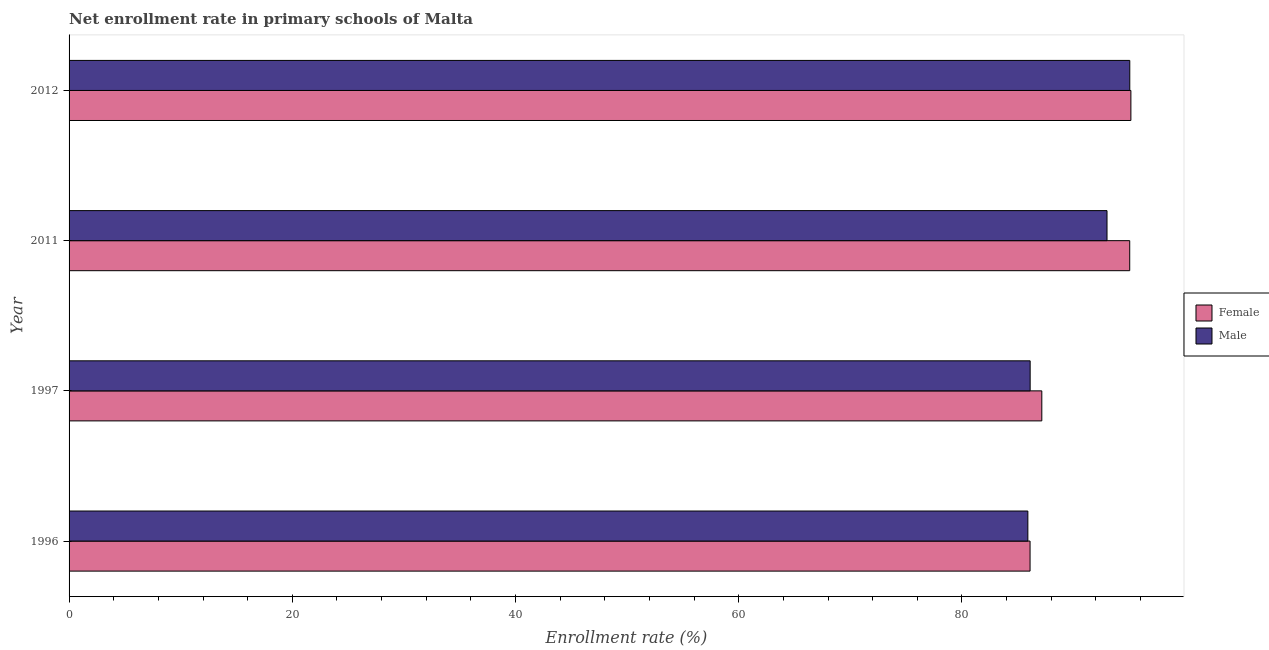How many different coloured bars are there?
Your response must be concise. 2. How many groups of bars are there?
Ensure brevity in your answer.  4. How many bars are there on the 4th tick from the top?
Your answer should be very brief. 2. What is the label of the 1st group of bars from the top?
Give a very brief answer. 2012. What is the enrollment rate of female students in 2012?
Your answer should be very brief. 95.14. Across all years, what is the maximum enrollment rate of female students?
Make the answer very short. 95.14. Across all years, what is the minimum enrollment rate of male students?
Offer a very short reply. 85.91. In which year was the enrollment rate of female students maximum?
Your response must be concise. 2012. What is the total enrollment rate of male students in the graph?
Keep it short and to the point. 360.05. What is the difference between the enrollment rate of male students in 1996 and that in 2012?
Make the answer very short. -9.13. What is the difference between the enrollment rate of male students in 1997 and the enrollment rate of female students in 2012?
Your answer should be very brief. -9.03. What is the average enrollment rate of female students per year?
Offer a very short reply. 90.86. In the year 2012, what is the difference between the enrollment rate of female students and enrollment rate of male students?
Your answer should be compact. 0.1. In how many years, is the enrollment rate of female students greater than 68 %?
Your answer should be compact. 4. What is the ratio of the enrollment rate of male students in 1996 to that in 2011?
Offer a very short reply. 0.92. What is the difference between the highest and the second highest enrollment rate of female students?
Provide a succinct answer. 0.1. What is the difference between the highest and the lowest enrollment rate of female students?
Ensure brevity in your answer.  9.03. Is the sum of the enrollment rate of female students in 1997 and 2011 greater than the maximum enrollment rate of male students across all years?
Your response must be concise. Yes. Are all the bars in the graph horizontal?
Your answer should be very brief. Yes. How many years are there in the graph?
Provide a short and direct response. 4. What is the title of the graph?
Give a very brief answer. Net enrollment rate in primary schools of Malta. What is the label or title of the X-axis?
Make the answer very short. Enrollment rate (%). What is the Enrollment rate (%) of Female in 1996?
Keep it short and to the point. 86.1. What is the Enrollment rate (%) of Male in 1996?
Make the answer very short. 85.91. What is the Enrollment rate (%) in Female in 1997?
Provide a succinct answer. 87.16. What is the Enrollment rate (%) in Male in 1997?
Your answer should be very brief. 86.11. What is the Enrollment rate (%) of Female in 2011?
Make the answer very short. 95.03. What is the Enrollment rate (%) of Male in 2011?
Your answer should be compact. 93. What is the Enrollment rate (%) in Female in 2012?
Give a very brief answer. 95.14. What is the Enrollment rate (%) of Male in 2012?
Provide a short and direct response. 95.04. Across all years, what is the maximum Enrollment rate (%) in Female?
Make the answer very short. 95.14. Across all years, what is the maximum Enrollment rate (%) in Male?
Offer a very short reply. 95.04. Across all years, what is the minimum Enrollment rate (%) of Female?
Your answer should be compact. 86.1. Across all years, what is the minimum Enrollment rate (%) in Male?
Provide a succinct answer. 85.91. What is the total Enrollment rate (%) of Female in the graph?
Offer a very short reply. 363.43. What is the total Enrollment rate (%) in Male in the graph?
Your response must be concise. 360.05. What is the difference between the Enrollment rate (%) of Female in 1996 and that in 1997?
Offer a terse response. -1.05. What is the difference between the Enrollment rate (%) of Male in 1996 and that in 1997?
Offer a very short reply. -0.21. What is the difference between the Enrollment rate (%) of Female in 1996 and that in 2011?
Your answer should be very brief. -8.93. What is the difference between the Enrollment rate (%) of Male in 1996 and that in 2011?
Offer a terse response. -7.09. What is the difference between the Enrollment rate (%) in Female in 1996 and that in 2012?
Offer a very short reply. -9.03. What is the difference between the Enrollment rate (%) of Male in 1996 and that in 2012?
Ensure brevity in your answer.  -9.13. What is the difference between the Enrollment rate (%) in Female in 1997 and that in 2011?
Make the answer very short. -7.88. What is the difference between the Enrollment rate (%) of Male in 1997 and that in 2011?
Make the answer very short. -6.89. What is the difference between the Enrollment rate (%) in Female in 1997 and that in 2012?
Your response must be concise. -7.98. What is the difference between the Enrollment rate (%) of Male in 1997 and that in 2012?
Your answer should be very brief. -8.93. What is the difference between the Enrollment rate (%) in Female in 2011 and that in 2012?
Offer a terse response. -0.1. What is the difference between the Enrollment rate (%) of Male in 2011 and that in 2012?
Provide a short and direct response. -2.04. What is the difference between the Enrollment rate (%) of Female in 1996 and the Enrollment rate (%) of Male in 1997?
Your answer should be very brief. -0.01. What is the difference between the Enrollment rate (%) in Female in 1996 and the Enrollment rate (%) in Male in 2011?
Your answer should be compact. -6.89. What is the difference between the Enrollment rate (%) of Female in 1996 and the Enrollment rate (%) of Male in 2012?
Your response must be concise. -8.93. What is the difference between the Enrollment rate (%) in Female in 1997 and the Enrollment rate (%) in Male in 2011?
Make the answer very short. -5.84. What is the difference between the Enrollment rate (%) of Female in 1997 and the Enrollment rate (%) of Male in 2012?
Provide a succinct answer. -7.88. What is the difference between the Enrollment rate (%) in Female in 2011 and the Enrollment rate (%) in Male in 2012?
Your response must be concise. -0.01. What is the average Enrollment rate (%) in Female per year?
Provide a short and direct response. 90.86. What is the average Enrollment rate (%) in Male per year?
Offer a terse response. 90.01. In the year 1996, what is the difference between the Enrollment rate (%) of Female and Enrollment rate (%) of Male?
Make the answer very short. 0.2. In the year 1997, what is the difference between the Enrollment rate (%) of Female and Enrollment rate (%) of Male?
Your answer should be very brief. 1.05. In the year 2011, what is the difference between the Enrollment rate (%) in Female and Enrollment rate (%) in Male?
Make the answer very short. 2.04. In the year 2012, what is the difference between the Enrollment rate (%) in Female and Enrollment rate (%) in Male?
Offer a terse response. 0.1. What is the ratio of the Enrollment rate (%) in Female in 1996 to that in 1997?
Keep it short and to the point. 0.99. What is the ratio of the Enrollment rate (%) in Female in 1996 to that in 2011?
Your answer should be compact. 0.91. What is the ratio of the Enrollment rate (%) in Male in 1996 to that in 2011?
Keep it short and to the point. 0.92. What is the ratio of the Enrollment rate (%) in Female in 1996 to that in 2012?
Your answer should be very brief. 0.91. What is the ratio of the Enrollment rate (%) in Male in 1996 to that in 2012?
Provide a succinct answer. 0.9. What is the ratio of the Enrollment rate (%) of Female in 1997 to that in 2011?
Provide a short and direct response. 0.92. What is the ratio of the Enrollment rate (%) of Male in 1997 to that in 2011?
Your answer should be very brief. 0.93. What is the ratio of the Enrollment rate (%) of Female in 1997 to that in 2012?
Your answer should be very brief. 0.92. What is the ratio of the Enrollment rate (%) in Male in 1997 to that in 2012?
Make the answer very short. 0.91. What is the ratio of the Enrollment rate (%) in Female in 2011 to that in 2012?
Your answer should be very brief. 1. What is the ratio of the Enrollment rate (%) of Male in 2011 to that in 2012?
Provide a succinct answer. 0.98. What is the difference between the highest and the second highest Enrollment rate (%) of Female?
Offer a very short reply. 0.1. What is the difference between the highest and the second highest Enrollment rate (%) of Male?
Make the answer very short. 2.04. What is the difference between the highest and the lowest Enrollment rate (%) of Female?
Provide a succinct answer. 9.03. What is the difference between the highest and the lowest Enrollment rate (%) of Male?
Offer a very short reply. 9.13. 